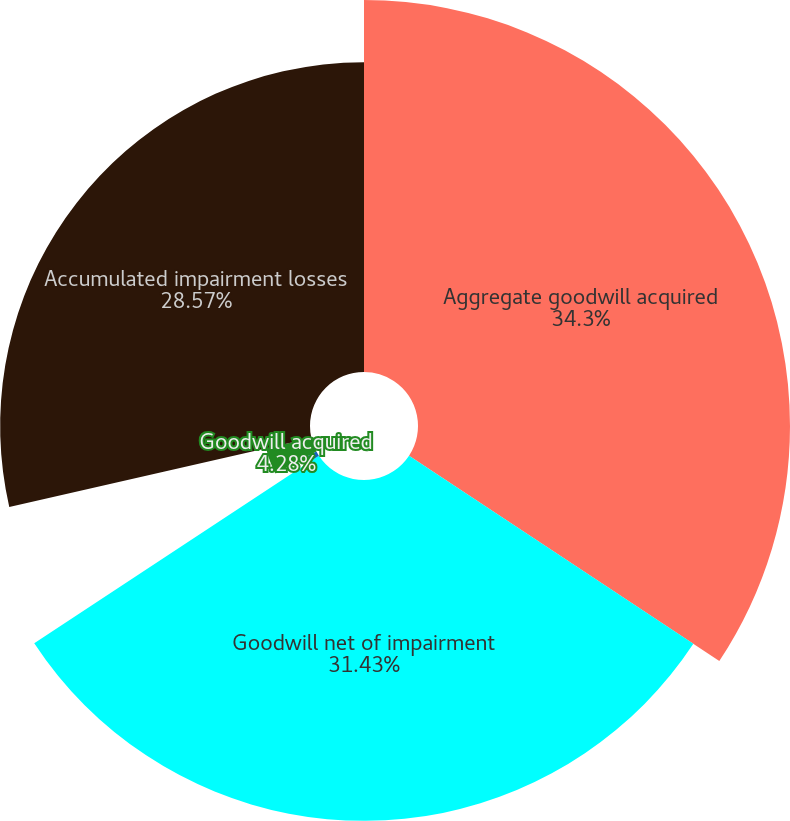<chart> <loc_0><loc_0><loc_500><loc_500><pie_chart><fcel>Aggregate goodwill acquired<fcel>Goodwill net of impairment<fcel>Adjustments<fcel>Goodwill acquired<fcel>Accumulated impairment losses<nl><fcel>34.3%<fcel>31.43%<fcel>1.42%<fcel>4.28%<fcel>28.57%<nl></chart> 